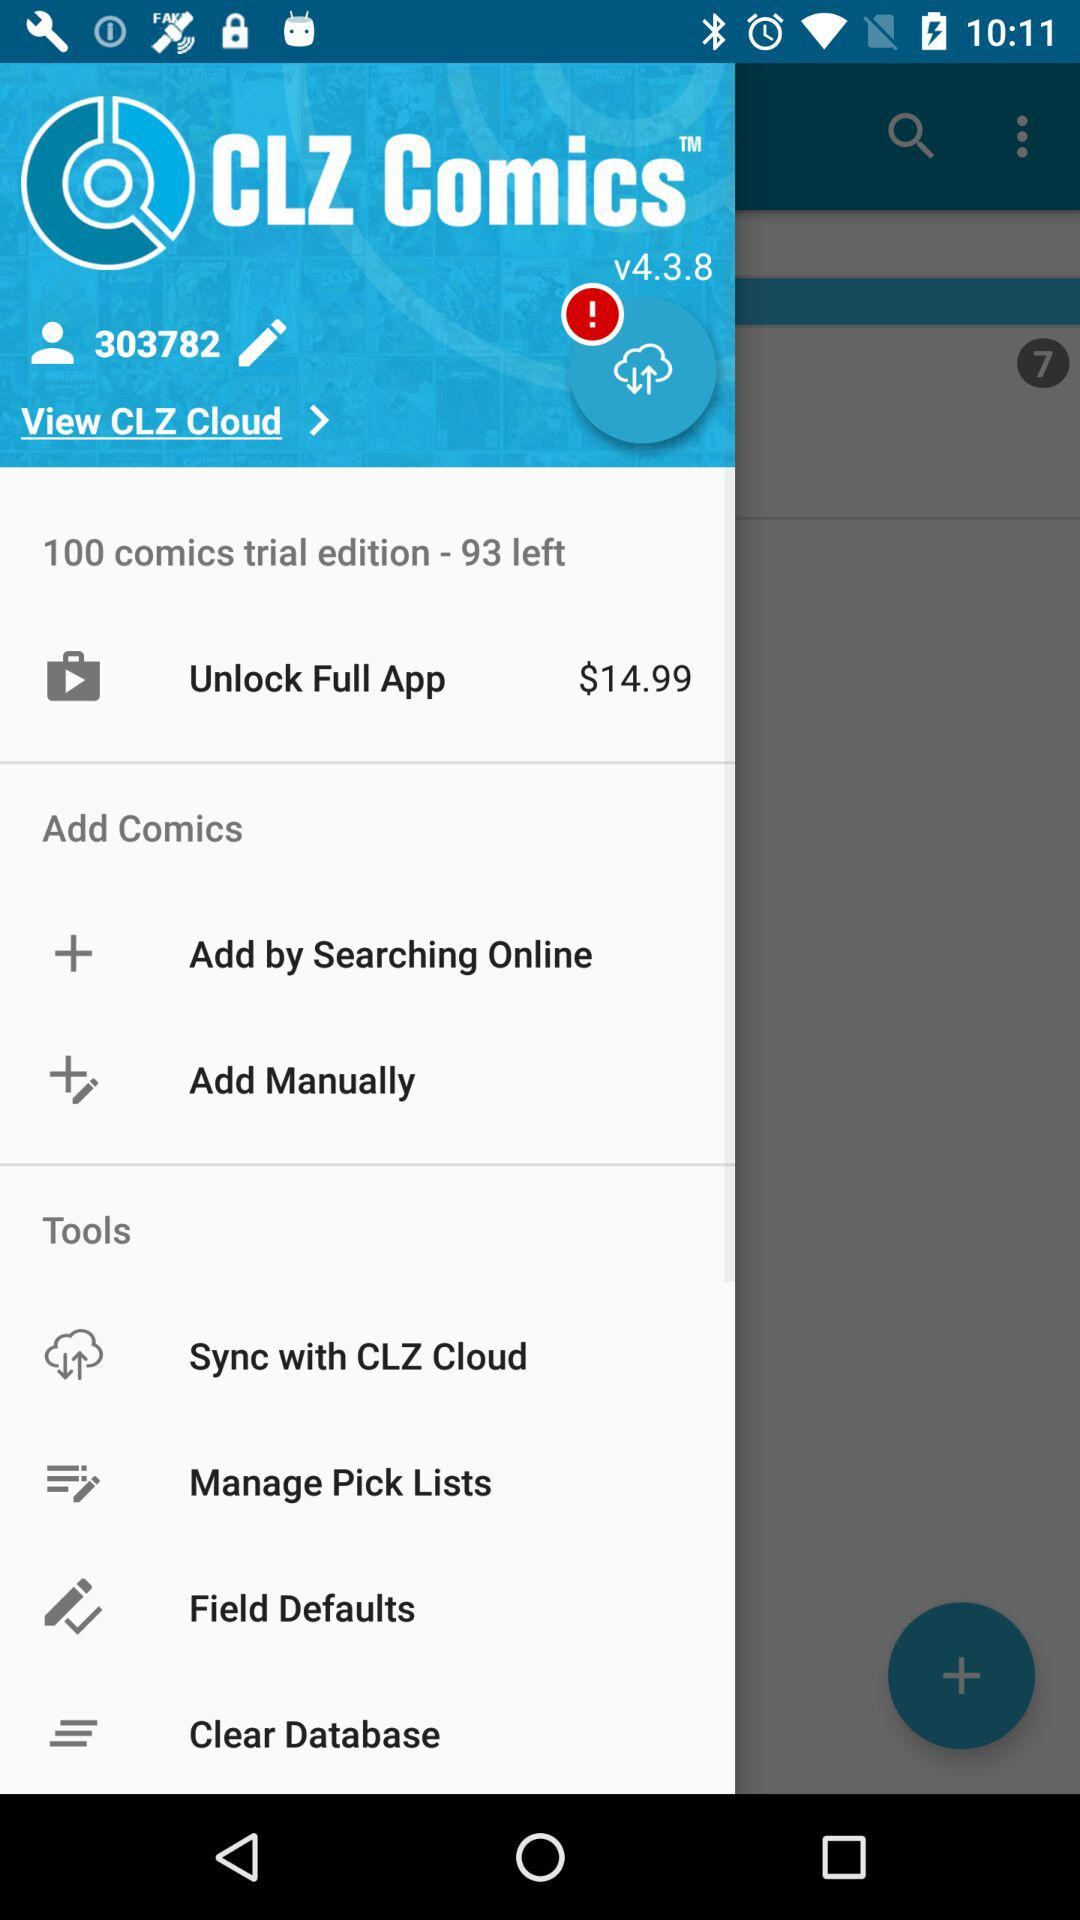Which version is this? This is the v4.3.8 version. 